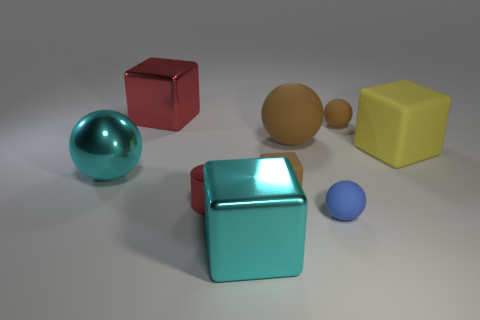Subtract all brown balls. How many balls are left? 2 Subtract all yellow blocks. How many blocks are left? 3 Subtract 1 blocks. How many blocks are left? 3 Add 1 tiny red metallic cylinders. How many objects exist? 10 Subtract all red cubes. How many brown spheres are left? 2 Add 6 blue balls. How many blue balls are left? 7 Add 5 big purple rubber spheres. How many big purple rubber spheres exist? 5 Subtract 1 red cylinders. How many objects are left? 8 Subtract all blocks. How many objects are left? 5 Subtract all yellow blocks. Subtract all green cylinders. How many blocks are left? 3 